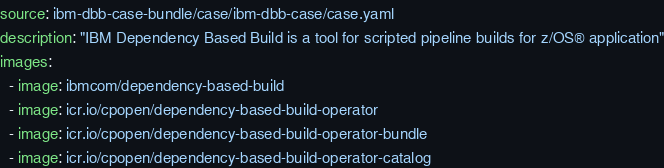Convert code to text. <code><loc_0><loc_0><loc_500><loc_500><_YAML_>source: ibm-dbb-case-bundle/case/ibm-dbb-case/case.yaml
description: "IBM Dependency Based Build is a tool for scripted pipeline builds for z/OS® application"
images:
  - image: ibmcom/dependency-based-build
  - image: icr.io/cpopen/dependency-based-build-operator
  - image: icr.io/cpopen/dependency-based-build-operator-bundle
  - image: icr.io/cpopen/dependency-based-build-operator-catalog
</code> 